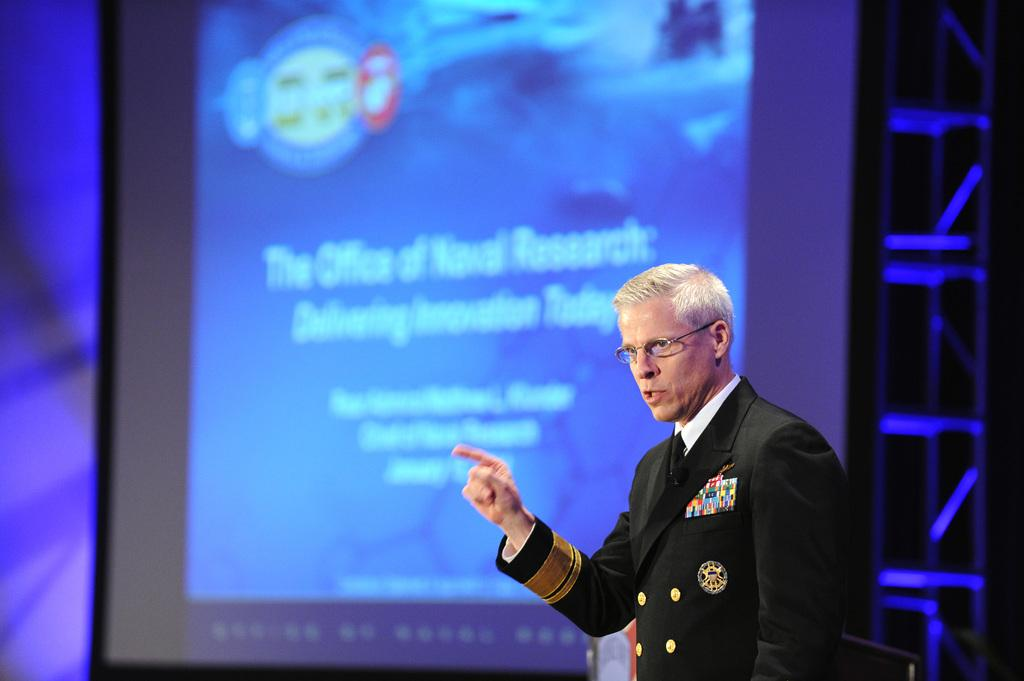What is the position of the man in the image? The man is standing at the right side of the image. What is the man wearing in the image? The man is wearing a black coat and glasses (specs). What can be seen in the background of the image? There is a powerpoint presentation in the background of the image. How many chickens are present in the image? There are no chickens present in the image. Are there any children visible in the image? There is no mention of children in the provided facts, so we cannot determine if they are present in the image. Is there a writer in the image? The provided facts do not mention a writer, so we cannot determine if there is one present in the image. 